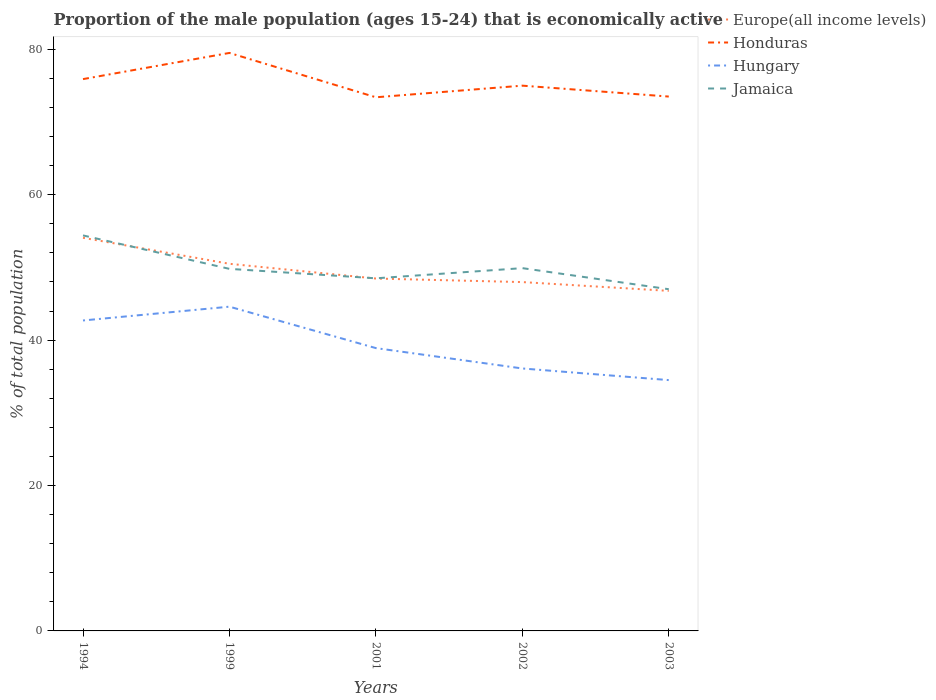Does the line corresponding to Jamaica intersect with the line corresponding to Hungary?
Your response must be concise. No. Across all years, what is the maximum proportion of the male population that is economically active in Honduras?
Your answer should be compact. 73.4. What is the difference between the highest and the second highest proportion of the male population that is economically active in Honduras?
Provide a succinct answer. 6.1. What is the difference between the highest and the lowest proportion of the male population that is economically active in Hungary?
Provide a succinct answer. 2. Is the proportion of the male population that is economically active in Europe(all income levels) strictly greater than the proportion of the male population that is economically active in Jamaica over the years?
Your response must be concise. No. How many lines are there?
Make the answer very short. 4. How many years are there in the graph?
Provide a short and direct response. 5. What is the difference between two consecutive major ticks on the Y-axis?
Offer a very short reply. 20. Are the values on the major ticks of Y-axis written in scientific E-notation?
Give a very brief answer. No. Where does the legend appear in the graph?
Make the answer very short. Top right. How many legend labels are there?
Offer a very short reply. 4. What is the title of the graph?
Ensure brevity in your answer.  Proportion of the male population (ages 15-24) that is economically active. What is the label or title of the X-axis?
Offer a terse response. Years. What is the label or title of the Y-axis?
Give a very brief answer. % of total population. What is the % of total population of Europe(all income levels) in 1994?
Your answer should be compact. 54.07. What is the % of total population of Honduras in 1994?
Your answer should be very brief. 75.9. What is the % of total population of Hungary in 1994?
Your answer should be compact. 42.7. What is the % of total population of Jamaica in 1994?
Offer a terse response. 54.4. What is the % of total population of Europe(all income levels) in 1999?
Provide a succinct answer. 50.5. What is the % of total population of Honduras in 1999?
Give a very brief answer. 79.5. What is the % of total population in Hungary in 1999?
Your response must be concise. 44.6. What is the % of total population in Jamaica in 1999?
Keep it short and to the point. 49.8. What is the % of total population of Europe(all income levels) in 2001?
Make the answer very short. 48.47. What is the % of total population in Honduras in 2001?
Your answer should be very brief. 73.4. What is the % of total population in Hungary in 2001?
Your answer should be very brief. 38.9. What is the % of total population in Jamaica in 2001?
Make the answer very short. 48.5. What is the % of total population in Europe(all income levels) in 2002?
Offer a very short reply. 47.98. What is the % of total population in Honduras in 2002?
Keep it short and to the point. 75. What is the % of total population of Hungary in 2002?
Your answer should be very brief. 36.1. What is the % of total population in Jamaica in 2002?
Keep it short and to the point. 49.9. What is the % of total population in Europe(all income levels) in 2003?
Provide a short and direct response. 46.77. What is the % of total population in Honduras in 2003?
Give a very brief answer. 73.5. What is the % of total population in Hungary in 2003?
Make the answer very short. 34.5. What is the % of total population in Jamaica in 2003?
Offer a very short reply. 47. Across all years, what is the maximum % of total population in Europe(all income levels)?
Offer a terse response. 54.07. Across all years, what is the maximum % of total population in Honduras?
Offer a very short reply. 79.5. Across all years, what is the maximum % of total population in Hungary?
Your response must be concise. 44.6. Across all years, what is the maximum % of total population of Jamaica?
Offer a very short reply. 54.4. Across all years, what is the minimum % of total population in Europe(all income levels)?
Ensure brevity in your answer.  46.77. Across all years, what is the minimum % of total population of Honduras?
Your response must be concise. 73.4. Across all years, what is the minimum % of total population in Hungary?
Give a very brief answer. 34.5. What is the total % of total population in Europe(all income levels) in the graph?
Keep it short and to the point. 247.8. What is the total % of total population of Honduras in the graph?
Keep it short and to the point. 377.3. What is the total % of total population of Hungary in the graph?
Keep it short and to the point. 196.8. What is the total % of total population in Jamaica in the graph?
Your answer should be very brief. 249.6. What is the difference between the % of total population in Europe(all income levels) in 1994 and that in 1999?
Your response must be concise. 3.58. What is the difference between the % of total population of Honduras in 1994 and that in 1999?
Make the answer very short. -3.6. What is the difference between the % of total population in Jamaica in 1994 and that in 1999?
Keep it short and to the point. 4.6. What is the difference between the % of total population of Europe(all income levels) in 1994 and that in 2001?
Provide a short and direct response. 5.6. What is the difference between the % of total population of Honduras in 1994 and that in 2001?
Your answer should be compact. 2.5. What is the difference between the % of total population in Hungary in 1994 and that in 2001?
Your response must be concise. 3.8. What is the difference between the % of total population in Jamaica in 1994 and that in 2001?
Make the answer very short. 5.9. What is the difference between the % of total population in Europe(all income levels) in 1994 and that in 2002?
Your answer should be compact. 6.09. What is the difference between the % of total population of Honduras in 1994 and that in 2002?
Provide a short and direct response. 0.9. What is the difference between the % of total population of Hungary in 1994 and that in 2002?
Ensure brevity in your answer.  6.6. What is the difference between the % of total population of Jamaica in 1994 and that in 2002?
Ensure brevity in your answer.  4.5. What is the difference between the % of total population of Europe(all income levels) in 1994 and that in 2003?
Provide a short and direct response. 7.3. What is the difference between the % of total population of Europe(all income levels) in 1999 and that in 2001?
Your answer should be very brief. 2.03. What is the difference between the % of total population in Honduras in 1999 and that in 2001?
Your answer should be very brief. 6.1. What is the difference between the % of total population of Hungary in 1999 and that in 2001?
Provide a short and direct response. 5.7. What is the difference between the % of total population in Jamaica in 1999 and that in 2001?
Ensure brevity in your answer.  1.3. What is the difference between the % of total population of Europe(all income levels) in 1999 and that in 2002?
Keep it short and to the point. 2.52. What is the difference between the % of total population in Honduras in 1999 and that in 2002?
Give a very brief answer. 4.5. What is the difference between the % of total population of Jamaica in 1999 and that in 2002?
Offer a very short reply. -0.1. What is the difference between the % of total population of Europe(all income levels) in 1999 and that in 2003?
Keep it short and to the point. 3.72. What is the difference between the % of total population of Europe(all income levels) in 2001 and that in 2002?
Ensure brevity in your answer.  0.49. What is the difference between the % of total population of Honduras in 2001 and that in 2002?
Ensure brevity in your answer.  -1.6. What is the difference between the % of total population in Hungary in 2001 and that in 2002?
Your answer should be compact. 2.8. What is the difference between the % of total population of Jamaica in 2001 and that in 2002?
Provide a succinct answer. -1.4. What is the difference between the % of total population of Europe(all income levels) in 2001 and that in 2003?
Keep it short and to the point. 1.7. What is the difference between the % of total population in Hungary in 2001 and that in 2003?
Give a very brief answer. 4.4. What is the difference between the % of total population of Jamaica in 2001 and that in 2003?
Provide a succinct answer. 1.5. What is the difference between the % of total population of Europe(all income levels) in 2002 and that in 2003?
Your response must be concise. 1.21. What is the difference between the % of total population of Honduras in 2002 and that in 2003?
Your response must be concise. 1.5. What is the difference between the % of total population in Europe(all income levels) in 1994 and the % of total population in Honduras in 1999?
Offer a terse response. -25.43. What is the difference between the % of total population of Europe(all income levels) in 1994 and the % of total population of Hungary in 1999?
Give a very brief answer. 9.47. What is the difference between the % of total population of Europe(all income levels) in 1994 and the % of total population of Jamaica in 1999?
Your answer should be compact. 4.27. What is the difference between the % of total population in Honduras in 1994 and the % of total population in Hungary in 1999?
Your answer should be very brief. 31.3. What is the difference between the % of total population of Honduras in 1994 and the % of total population of Jamaica in 1999?
Offer a terse response. 26.1. What is the difference between the % of total population of Hungary in 1994 and the % of total population of Jamaica in 1999?
Give a very brief answer. -7.1. What is the difference between the % of total population of Europe(all income levels) in 1994 and the % of total population of Honduras in 2001?
Keep it short and to the point. -19.33. What is the difference between the % of total population in Europe(all income levels) in 1994 and the % of total population in Hungary in 2001?
Your answer should be compact. 15.17. What is the difference between the % of total population of Europe(all income levels) in 1994 and the % of total population of Jamaica in 2001?
Your response must be concise. 5.57. What is the difference between the % of total population of Honduras in 1994 and the % of total population of Hungary in 2001?
Give a very brief answer. 37. What is the difference between the % of total population in Honduras in 1994 and the % of total population in Jamaica in 2001?
Your answer should be very brief. 27.4. What is the difference between the % of total population in Hungary in 1994 and the % of total population in Jamaica in 2001?
Provide a succinct answer. -5.8. What is the difference between the % of total population in Europe(all income levels) in 1994 and the % of total population in Honduras in 2002?
Keep it short and to the point. -20.93. What is the difference between the % of total population of Europe(all income levels) in 1994 and the % of total population of Hungary in 2002?
Ensure brevity in your answer.  17.97. What is the difference between the % of total population in Europe(all income levels) in 1994 and the % of total population in Jamaica in 2002?
Your answer should be compact. 4.17. What is the difference between the % of total population of Honduras in 1994 and the % of total population of Hungary in 2002?
Give a very brief answer. 39.8. What is the difference between the % of total population in Honduras in 1994 and the % of total population in Jamaica in 2002?
Your response must be concise. 26. What is the difference between the % of total population in Europe(all income levels) in 1994 and the % of total population in Honduras in 2003?
Keep it short and to the point. -19.43. What is the difference between the % of total population in Europe(all income levels) in 1994 and the % of total population in Hungary in 2003?
Your answer should be compact. 19.57. What is the difference between the % of total population of Europe(all income levels) in 1994 and the % of total population of Jamaica in 2003?
Your response must be concise. 7.07. What is the difference between the % of total population in Honduras in 1994 and the % of total population in Hungary in 2003?
Your response must be concise. 41.4. What is the difference between the % of total population of Honduras in 1994 and the % of total population of Jamaica in 2003?
Your answer should be very brief. 28.9. What is the difference between the % of total population in Hungary in 1994 and the % of total population in Jamaica in 2003?
Provide a short and direct response. -4.3. What is the difference between the % of total population of Europe(all income levels) in 1999 and the % of total population of Honduras in 2001?
Offer a very short reply. -22.9. What is the difference between the % of total population in Europe(all income levels) in 1999 and the % of total population in Hungary in 2001?
Your answer should be very brief. 11.6. What is the difference between the % of total population in Europe(all income levels) in 1999 and the % of total population in Jamaica in 2001?
Make the answer very short. 2. What is the difference between the % of total population in Honduras in 1999 and the % of total population in Hungary in 2001?
Provide a short and direct response. 40.6. What is the difference between the % of total population in Europe(all income levels) in 1999 and the % of total population in Honduras in 2002?
Keep it short and to the point. -24.5. What is the difference between the % of total population in Europe(all income levels) in 1999 and the % of total population in Hungary in 2002?
Make the answer very short. 14.4. What is the difference between the % of total population in Europe(all income levels) in 1999 and the % of total population in Jamaica in 2002?
Offer a very short reply. 0.6. What is the difference between the % of total population in Honduras in 1999 and the % of total population in Hungary in 2002?
Offer a terse response. 43.4. What is the difference between the % of total population in Honduras in 1999 and the % of total population in Jamaica in 2002?
Your response must be concise. 29.6. What is the difference between the % of total population in Hungary in 1999 and the % of total population in Jamaica in 2002?
Provide a short and direct response. -5.3. What is the difference between the % of total population of Europe(all income levels) in 1999 and the % of total population of Honduras in 2003?
Ensure brevity in your answer.  -23. What is the difference between the % of total population of Europe(all income levels) in 1999 and the % of total population of Hungary in 2003?
Your answer should be compact. 16. What is the difference between the % of total population in Europe(all income levels) in 1999 and the % of total population in Jamaica in 2003?
Provide a short and direct response. 3.5. What is the difference between the % of total population of Honduras in 1999 and the % of total population of Jamaica in 2003?
Offer a very short reply. 32.5. What is the difference between the % of total population in Europe(all income levels) in 2001 and the % of total population in Honduras in 2002?
Your response must be concise. -26.53. What is the difference between the % of total population of Europe(all income levels) in 2001 and the % of total population of Hungary in 2002?
Provide a succinct answer. 12.37. What is the difference between the % of total population in Europe(all income levels) in 2001 and the % of total population in Jamaica in 2002?
Make the answer very short. -1.43. What is the difference between the % of total population in Honduras in 2001 and the % of total population in Hungary in 2002?
Your answer should be very brief. 37.3. What is the difference between the % of total population of Hungary in 2001 and the % of total population of Jamaica in 2002?
Ensure brevity in your answer.  -11. What is the difference between the % of total population of Europe(all income levels) in 2001 and the % of total population of Honduras in 2003?
Offer a terse response. -25.03. What is the difference between the % of total population of Europe(all income levels) in 2001 and the % of total population of Hungary in 2003?
Offer a terse response. 13.97. What is the difference between the % of total population of Europe(all income levels) in 2001 and the % of total population of Jamaica in 2003?
Keep it short and to the point. 1.47. What is the difference between the % of total population of Honduras in 2001 and the % of total population of Hungary in 2003?
Keep it short and to the point. 38.9. What is the difference between the % of total population in Honduras in 2001 and the % of total population in Jamaica in 2003?
Your answer should be very brief. 26.4. What is the difference between the % of total population of Europe(all income levels) in 2002 and the % of total population of Honduras in 2003?
Your answer should be very brief. -25.52. What is the difference between the % of total population in Europe(all income levels) in 2002 and the % of total population in Hungary in 2003?
Ensure brevity in your answer.  13.48. What is the difference between the % of total population of Europe(all income levels) in 2002 and the % of total population of Jamaica in 2003?
Offer a terse response. 0.98. What is the difference between the % of total population of Honduras in 2002 and the % of total population of Hungary in 2003?
Give a very brief answer. 40.5. What is the difference between the % of total population of Honduras in 2002 and the % of total population of Jamaica in 2003?
Provide a short and direct response. 28. What is the average % of total population in Europe(all income levels) per year?
Keep it short and to the point. 49.56. What is the average % of total population of Honduras per year?
Keep it short and to the point. 75.46. What is the average % of total population in Hungary per year?
Your answer should be very brief. 39.36. What is the average % of total population in Jamaica per year?
Your response must be concise. 49.92. In the year 1994, what is the difference between the % of total population of Europe(all income levels) and % of total population of Honduras?
Provide a short and direct response. -21.83. In the year 1994, what is the difference between the % of total population in Europe(all income levels) and % of total population in Hungary?
Provide a succinct answer. 11.37. In the year 1994, what is the difference between the % of total population of Europe(all income levels) and % of total population of Jamaica?
Keep it short and to the point. -0.33. In the year 1994, what is the difference between the % of total population of Honduras and % of total population of Hungary?
Ensure brevity in your answer.  33.2. In the year 1994, what is the difference between the % of total population in Honduras and % of total population in Jamaica?
Keep it short and to the point. 21.5. In the year 1994, what is the difference between the % of total population of Hungary and % of total population of Jamaica?
Provide a succinct answer. -11.7. In the year 1999, what is the difference between the % of total population of Europe(all income levels) and % of total population of Honduras?
Provide a short and direct response. -29. In the year 1999, what is the difference between the % of total population in Europe(all income levels) and % of total population in Hungary?
Your answer should be very brief. 5.9. In the year 1999, what is the difference between the % of total population of Europe(all income levels) and % of total population of Jamaica?
Give a very brief answer. 0.7. In the year 1999, what is the difference between the % of total population in Honduras and % of total population in Hungary?
Provide a short and direct response. 34.9. In the year 1999, what is the difference between the % of total population in Honduras and % of total population in Jamaica?
Provide a succinct answer. 29.7. In the year 2001, what is the difference between the % of total population of Europe(all income levels) and % of total population of Honduras?
Provide a short and direct response. -24.93. In the year 2001, what is the difference between the % of total population in Europe(all income levels) and % of total population in Hungary?
Keep it short and to the point. 9.57. In the year 2001, what is the difference between the % of total population in Europe(all income levels) and % of total population in Jamaica?
Give a very brief answer. -0.03. In the year 2001, what is the difference between the % of total population of Honduras and % of total population of Hungary?
Ensure brevity in your answer.  34.5. In the year 2001, what is the difference between the % of total population of Honduras and % of total population of Jamaica?
Your answer should be very brief. 24.9. In the year 2002, what is the difference between the % of total population in Europe(all income levels) and % of total population in Honduras?
Your answer should be very brief. -27.02. In the year 2002, what is the difference between the % of total population of Europe(all income levels) and % of total population of Hungary?
Offer a terse response. 11.88. In the year 2002, what is the difference between the % of total population of Europe(all income levels) and % of total population of Jamaica?
Your response must be concise. -1.92. In the year 2002, what is the difference between the % of total population of Honduras and % of total population of Hungary?
Your answer should be very brief. 38.9. In the year 2002, what is the difference between the % of total population in Honduras and % of total population in Jamaica?
Ensure brevity in your answer.  25.1. In the year 2003, what is the difference between the % of total population of Europe(all income levels) and % of total population of Honduras?
Make the answer very short. -26.73. In the year 2003, what is the difference between the % of total population of Europe(all income levels) and % of total population of Hungary?
Provide a succinct answer. 12.27. In the year 2003, what is the difference between the % of total population of Europe(all income levels) and % of total population of Jamaica?
Your answer should be compact. -0.23. In the year 2003, what is the difference between the % of total population in Honduras and % of total population in Jamaica?
Give a very brief answer. 26.5. In the year 2003, what is the difference between the % of total population of Hungary and % of total population of Jamaica?
Your answer should be compact. -12.5. What is the ratio of the % of total population in Europe(all income levels) in 1994 to that in 1999?
Offer a very short reply. 1.07. What is the ratio of the % of total population of Honduras in 1994 to that in 1999?
Offer a very short reply. 0.95. What is the ratio of the % of total population of Hungary in 1994 to that in 1999?
Keep it short and to the point. 0.96. What is the ratio of the % of total population in Jamaica in 1994 to that in 1999?
Give a very brief answer. 1.09. What is the ratio of the % of total population of Europe(all income levels) in 1994 to that in 2001?
Provide a short and direct response. 1.12. What is the ratio of the % of total population in Honduras in 1994 to that in 2001?
Your response must be concise. 1.03. What is the ratio of the % of total population of Hungary in 1994 to that in 2001?
Offer a terse response. 1.1. What is the ratio of the % of total population of Jamaica in 1994 to that in 2001?
Offer a very short reply. 1.12. What is the ratio of the % of total population in Europe(all income levels) in 1994 to that in 2002?
Your answer should be very brief. 1.13. What is the ratio of the % of total population of Hungary in 1994 to that in 2002?
Make the answer very short. 1.18. What is the ratio of the % of total population of Jamaica in 1994 to that in 2002?
Provide a short and direct response. 1.09. What is the ratio of the % of total population of Europe(all income levels) in 1994 to that in 2003?
Give a very brief answer. 1.16. What is the ratio of the % of total population in Honduras in 1994 to that in 2003?
Offer a very short reply. 1.03. What is the ratio of the % of total population of Hungary in 1994 to that in 2003?
Provide a succinct answer. 1.24. What is the ratio of the % of total population of Jamaica in 1994 to that in 2003?
Offer a very short reply. 1.16. What is the ratio of the % of total population of Europe(all income levels) in 1999 to that in 2001?
Your answer should be very brief. 1.04. What is the ratio of the % of total population of Honduras in 1999 to that in 2001?
Make the answer very short. 1.08. What is the ratio of the % of total population in Hungary in 1999 to that in 2001?
Your response must be concise. 1.15. What is the ratio of the % of total population in Jamaica in 1999 to that in 2001?
Your response must be concise. 1.03. What is the ratio of the % of total population in Europe(all income levels) in 1999 to that in 2002?
Keep it short and to the point. 1.05. What is the ratio of the % of total population of Honduras in 1999 to that in 2002?
Your response must be concise. 1.06. What is the ratio of the % of total population in Hungary in 1999 to that in 2002?
Your answer should be very brief. 1.24. What is the ratio of the % of total population of Jamaica in 1999 to that in 2002?
Offer a terse response. 1. What is the ratio of the % of total population of Europe(all income levels) in 1999 to that in 2003?
Provide a succinct answer. 1.08. What is the ratio of the % of total population in Honduras in 1999 to that in 2003?
Your answer should be compact. 1.08. What is the ratio of the % of total population in Hungary in 1999 to that in 2003?
Give a very brief answer. 1.29. What is the ratio of the % of total population in Jamaica in 1999 to that in 2003?
Keep it short and to the point. 1.06. What is the ratio of the % of total population in Europe(all income levels) in 2001 to that in 2002?
Your answer should be compact. 1.01. What is the ratio of the % of total population of Honduras in 2001 to that in 2002?
Your answer should be compact. 0.98. What is the ratio of the % of total population in Hungary in 2001 to that in 2002?
Ensure brevity in your answer.  1.08. What is the ratio of the % of total population in Jamaica in 2001 to that in 2002?
Your response must be concise. 0.97. What is the ratio of the % of total population of Europe(all income levels) in 2001 to that in 2003?
Offer a terse response. 1.04. What is the ratio of the % of total population of Honduras in 2001 to that in 2003?
Keep it short and to the point. 1. What is the ratio of the % of total population in Hungary in 2001 to that in 2003?
Offer a very short reply. 1.13. What is the ratio of the % of total population in Jamaica in 2001 to that in 2003?
Offer a very short reply. 1.03. What is the ratio of the % of total population in Europe(all income levels) in 2002 to that in 2003?
Your response must be concise. 1.03. What is the ratio of the % of total population of Honduras in 2002 to that in 2003?
Offer a very short reply. 1.02. What is the ratio of the % of total population of Hungary in 2002 to that in 2003?
Provide a short and direct response. 1.05. What is the ratio of the % of total population of Jamaica in 2002 to that in 2003?
Offer a very short reply. 1.06. What is the difference between the highest and the second highest % of total population in Europe(all income levels)?
Your answer should be compact. 3.58. What is the difference between the highest and the second highest % of total population of Honduras?
Make the answer very short. 3.6. What is the difference between the highest and the lowest % of total population of Europe(all income levels)?
Provide a short and direct response. 7.3. What is the difference between the highest and the lowest % of total population of Honduras?
Give a very brief answer. 6.1. 